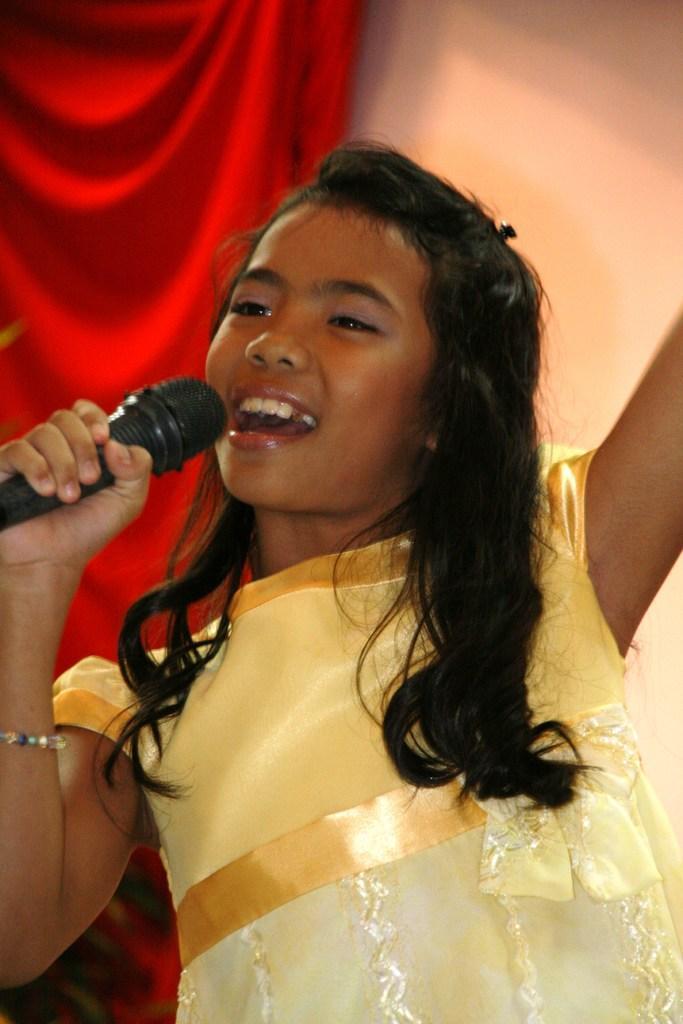Could you give a brief overview of what you see in this image? A girl with yellow frock and long hair singing on a mic ,which she held in her right hand , behind her there is red cloth and wall. 